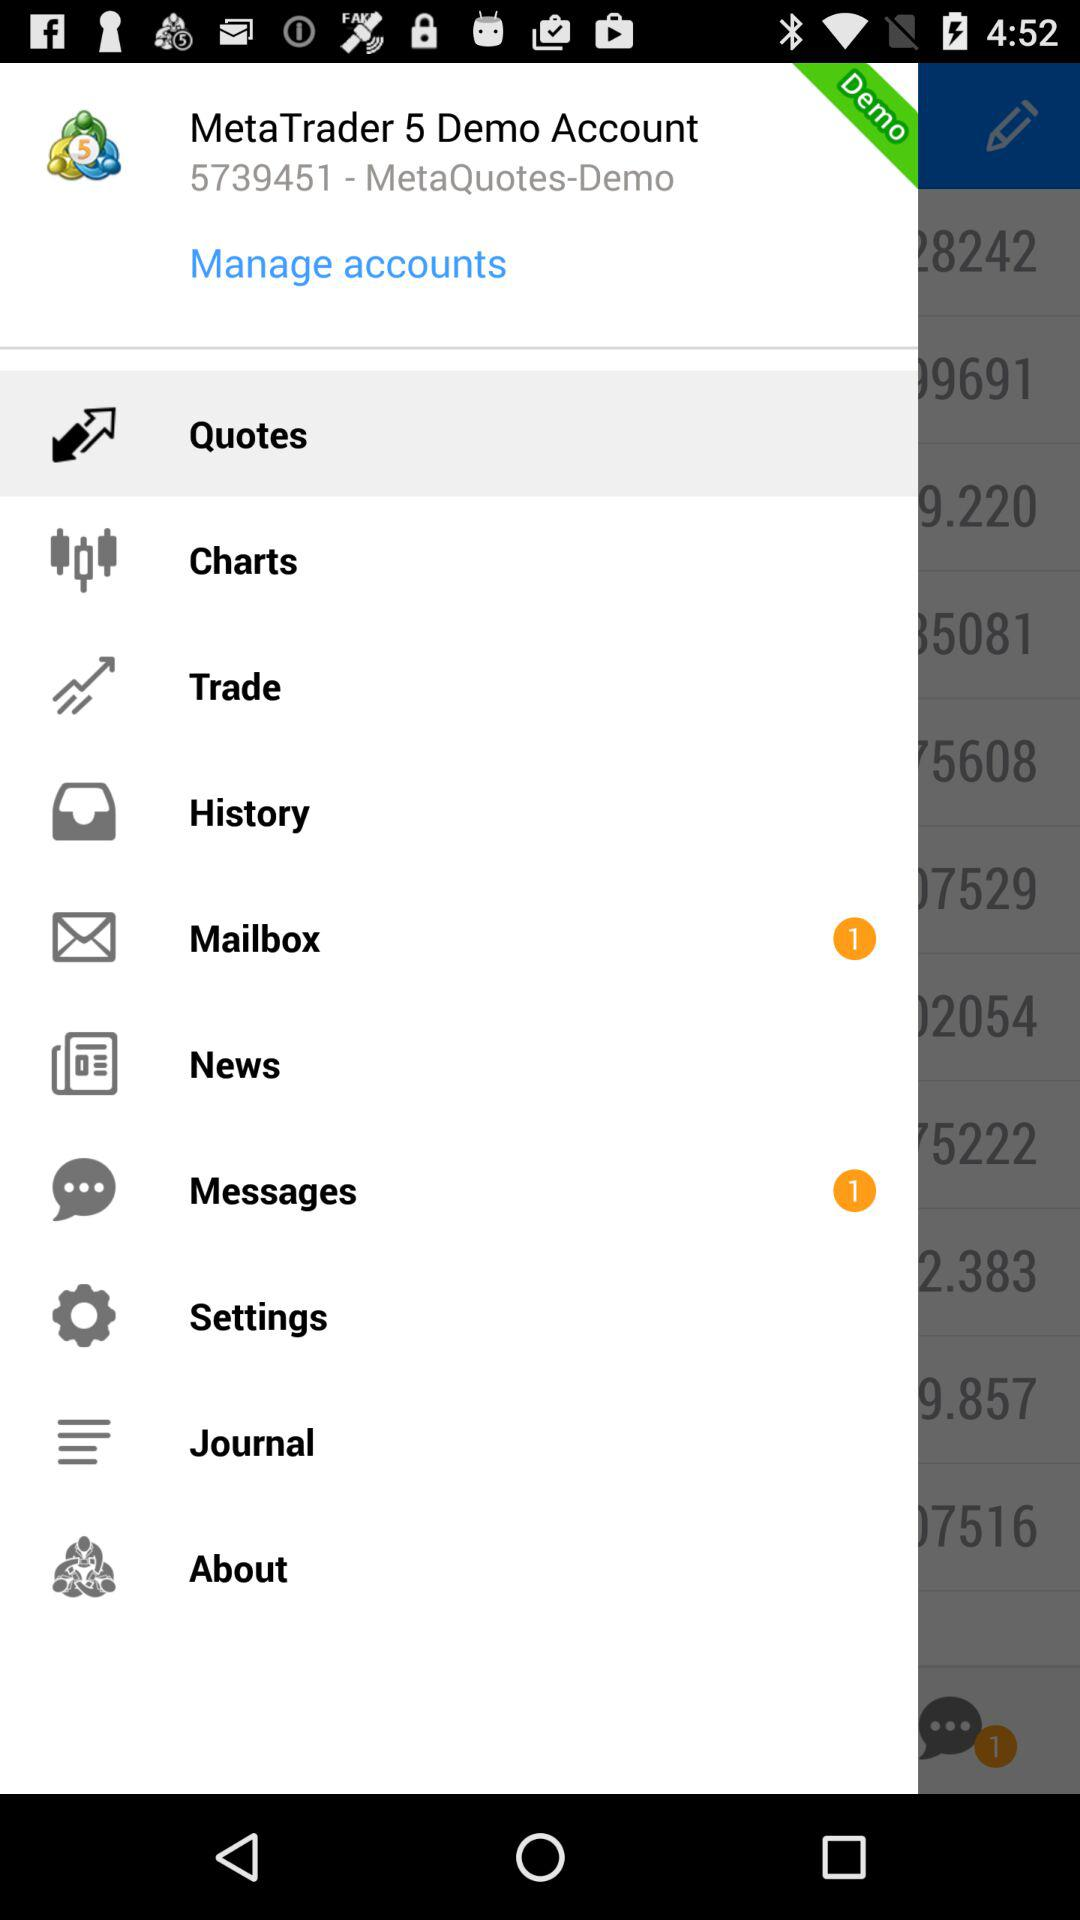What is the user name?
When the provided information is insufficient, respond with <no answer>. <no answer> 